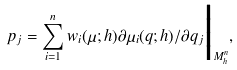Convert formula to latex. <formula><loc_0><loc_0><loc_500><loc_500>p _ { j } = \sum _ { i = 1 } ^ { n } w _ { i } ( \mu ; h ) \partial \mu _ { i } ( q ; h ) / \partial q _ { j } \Big | _ { M _ { h } ^ { n } } ,</formula> 